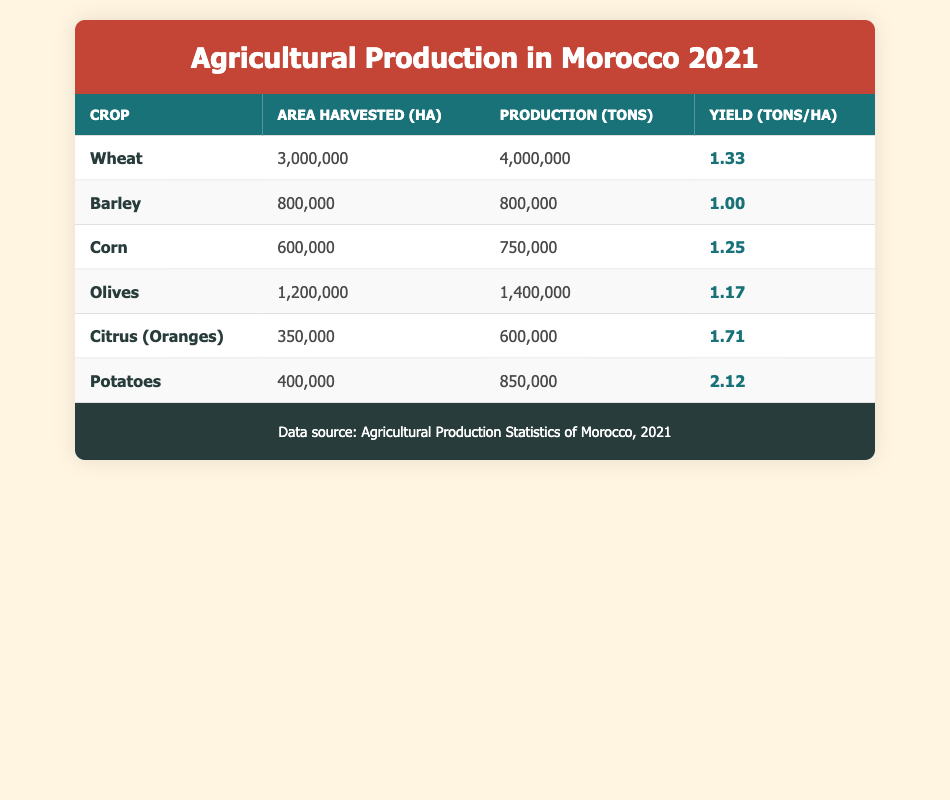What crop had the highest production in tons? Looking at the production column in the table, Wheat has the highest production value at 4,000,000 tons.
Answer: Wheat What is the yield of Potatoes in tons per hectare? The yield for Potatoes is given in the table as 2.12 tons/ha.
Answer: 2.12 How many hectares were harvested for Barley? The area harvested for Barley is listed directly in the table as 800,000 ha.
Answer: 800,000 ha What is the total area harvested for Wheat and Corn combined? The area harvested for Wheat is 3,000,000 ha and for Corn is 600,000 ha. Summing these gives 3,000,000 + 600,000 = 3,600,000 ha.
Answer: 3,600,000 ha Did Citrus (Oranges) have a higher yield than Olives? The yield of Citrus (Oranges) is 1.71 tons/ha and Olives have a yield of 1.17 tons/ha, therefore Citrus (Oranges) has a higher yield.
Answer: Yes What crop had the lowest yield in tons per hectare? By looking through the yields, Barley has the lowest yield of 1.00 tons/ha.
Answer: Barley Is the total production of Potatoes greater than that of Olives? The production of Potatoes is 850,000 tons while that of Olives is 1,400,000 tons. Since 850,000 is less than 1,400,000, Potatoes have a lower production.
Answer: No What is the average yield of all crops listed in the table? The yields are 1.33, 1.00, 1.25, 1.17, 1.71, and 2.12. Adding these yields gives a total of 7.58. There are six crops, so the average yield is 7.58/6 = 1.2633, which rounds to 1.26 tons/ha.
Answer: 1.26 tons/ha Which crop has an area harvested between 500,000 ha and 1,000,000 ha? Looking at the area harvested column, Barley (800,000 ha) falls within this range, while Corn is at 600,000 ha, which also qualifies, making both Barley and Corn valid.
Answer: Barley and Corn 